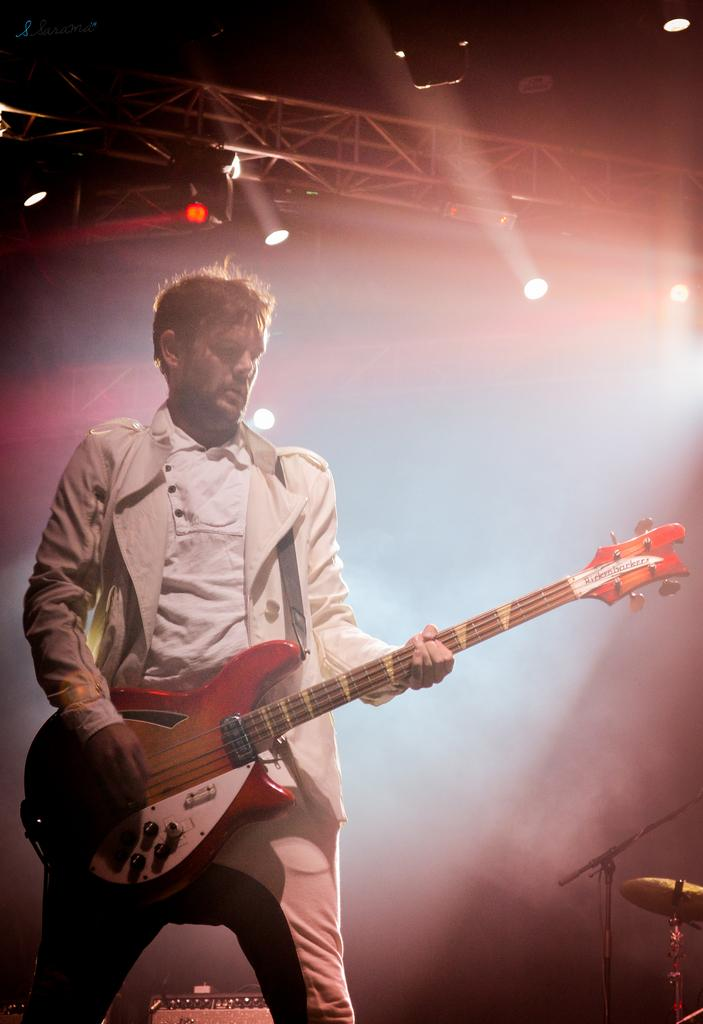What is the man on the left side of the image doing? The man is playing a guitar. What can be seen at the top of the image? There are lights visible at the top of the image. What musical instrument is located in the bottom right corner of the image? There are drums in the bottom right corner of the image. Reasoning: Let' Let's think step by step in order to produce the conversation. We start by identifying the main subject in the image, which is the man playing the guitar. Then, we expand the conversation to include other elements of the image, such as the lights at the top and the drums in the bottom right corner. Each question is designed to elicit a specific detail about the image that is known from the provided facts. Absurd Question/Answer: What letters are visible on the guitar in the image? There are no letters visible on the guitar in the image. What condition is the example of the guitar in? There is no example of a guitar in the image; it is a real guitar being played by the man. 